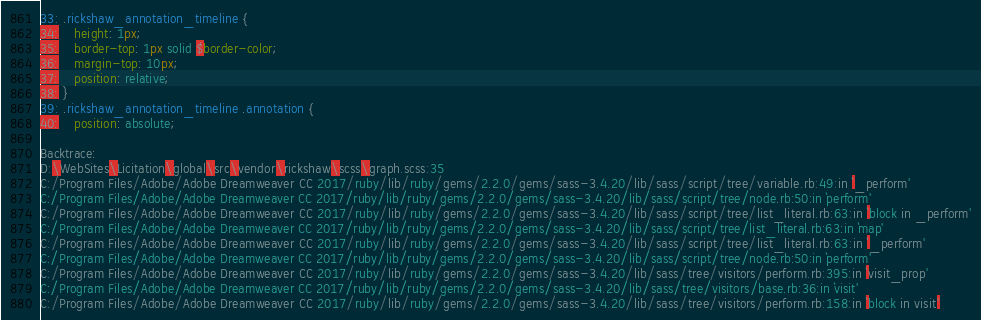<code> <loc_0><loc_0><loc_500><loc_500><_CSS_>33: .rickshaw_annotation_timeline {
34: 	height: 1px;
35: 	border-top: 1px solid $border-color;
36: 	margin-top: 10px;
37: 	position: relative;
38: }
39: .rickshaw_annotation_timeline .annotation {
40: 	position: absolute;

Backtrace:
D:\WebSites\Licitation\global\src\vendor\rickshaw\scss\graph.scss:35
C:/Program Files/Adobe/Adobe Dreamweaver CC 2017/ruby/lib/ruby/gems/2.2.0/gems/sass-3.4.20/lib/sass/script/tree/variable.rb:49:in `_perform'
C:/Program Files/Adobe/Adobe Dreamweaver CC 2017/ruby/lib/ruby/gems/2.2.0/gems/sass-3.4.20/lib/sass/script/tree/node.rb:50:in `perform'
C:/Program Files/Adobe/Adobe Dreamweaver CC 2017/ruby/lib/ruby/gems/2.2.0/gems/sass-3.4.20/lib/sass/script/tree/list_literal.rb:63:in `block in _perform'
C:/Program Files/Adobe/Adobe Dreamweaver CC 2017/ruby/lib/ruby/gems/2.2.0/gems/sass-3.4.20/lib/sass/script/tree/list_literal.rb:63:in `map'
C:/Program Files/Adobe/Adobe Dreamweaver CC 2017/ruby/lib/ruby/gems/2.2.0/gems/sass-3.4.20/lib/sass/script/tree/list_literal.rb:63:in `_perform'
C:/Program Files/Adobe/Adobe Dreamweaver CC 2017/ruby/lib/ruby/gems/2.2.0/gems/sass-3.4.20/lib/sass/script/tree/node.rb:50:in `perform'
C:/Program Files/Adobe/Adobe Dreamweaver CC 2017/ruby/lib/ruby/gems/2.2.0/gems/sass-3.4.20/lib/sass/tree/visitors/perform.rb:395:in `visit_prop'
C:/Program Files/Adobe/Adobe Dreamweaver CC 2017/ruby/lib/ruby/gems/2.2.0/gems/sass-3.4.20/lib/sass/tree/visitors/base.rb:36:in `visit'
C:/Program Files/Adobe/Adobe Dreamweaver CC 2017/ruby/lib/ruby/gems/2.2.0/gems/sass-3.4.20/lib/sass/tree/visitors/perform.rb:158:in `block in visit'</code> 